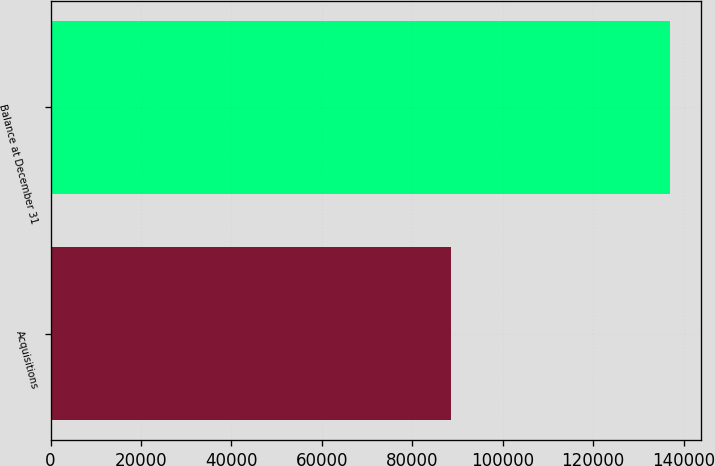Convert chart. <chart><loc_0><loc_0><loc_500><loc_500><bar_chart><fcel>Acquisitions<fcel>Balance at December 31<nl><fcel>88611<fcel>137027<nl></chart> 